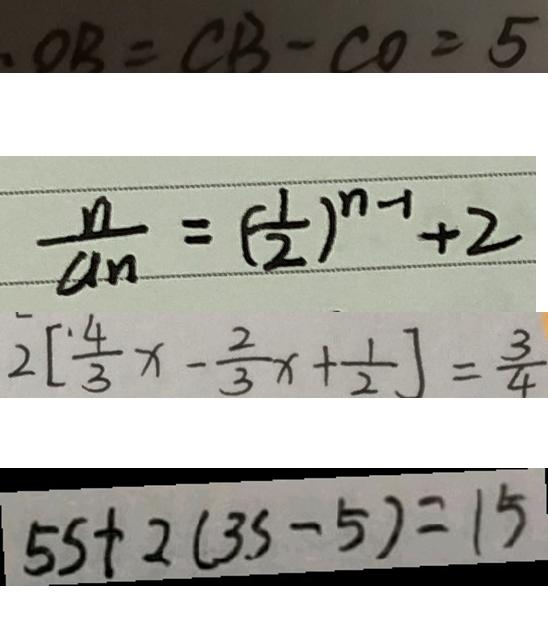<formula> <loc_0><loc_0><loc_500><loc_500>. O B = C B - C O = 5 
 \frac { n } { a _ { n } } = ( \frac { 1 } { 2 } ) ^ { n - 1 } + 2 
 2 [ \frac { 4 } { 3 } x - \frac { 2 } { 3 } x + \frac { 1 } { 2 } ] = \frac { 3 } { 4 } 
 5 5 + 2 ( 3 5 - 5 ) = 1 5</formula> 